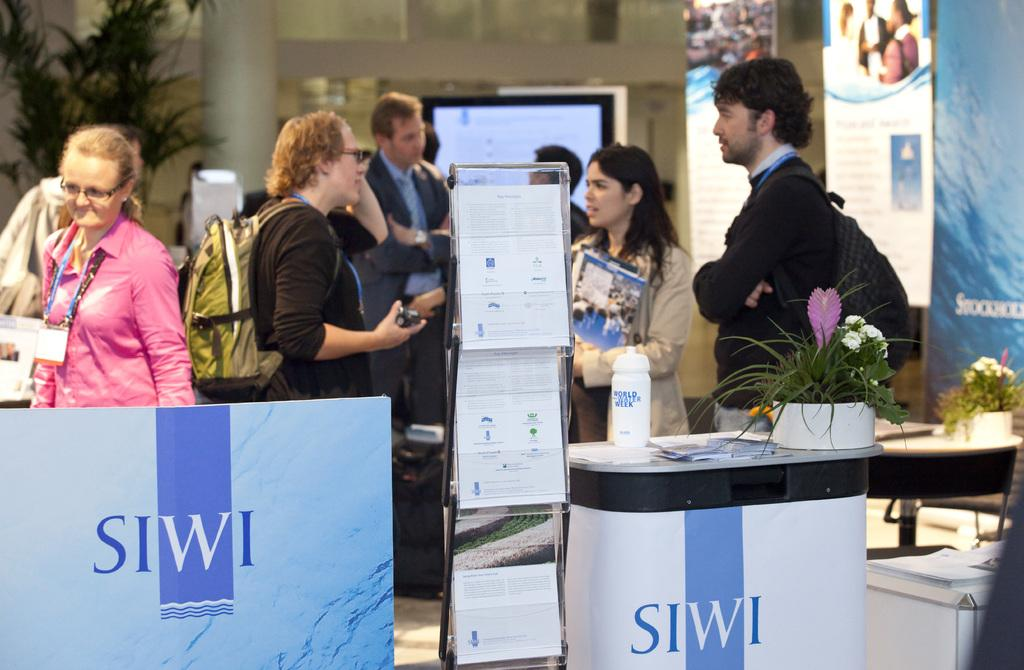Provide a one-sentence caption for the provided image. The SIWI logo can be seen in a room with several people. 